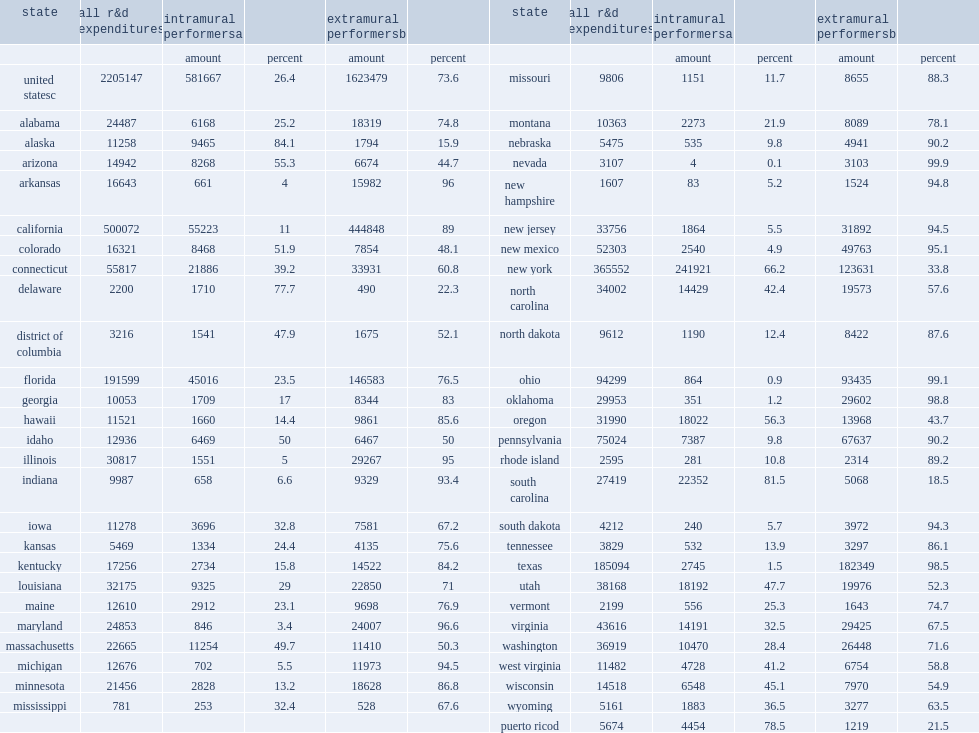How many thousand dollars of intramural r&d performed by state agencies in fy 2015? 581667.0. How many thousand dollars did new york account of the $582 thousand of intramural r&d performed by state agencies in fy 2015? 241921.0. How many thousand dollars did california account of the $582 thousand of intramural r&d performed by state agencies in fy 2015? 55223.0. How many thousand dollars did florida account of the $582 thousand of intramural r&d performed by state agencies in fy 2015? 45016.0. How many thousand dollars did south carolina account of the $582 thousand of intramural r&d performed by state agencies in fy 2015? 22352.0. How many thousand dollars did connecticut account of the $582 thousand of intramural r&d performed by state agencies in fy 2015? 21886.0. How many percent did five states account of the $582 million of intramural r&d performed by state agencies in fy 2015: new york, california, florida, south carolina, and connecticut? 0.664294. 